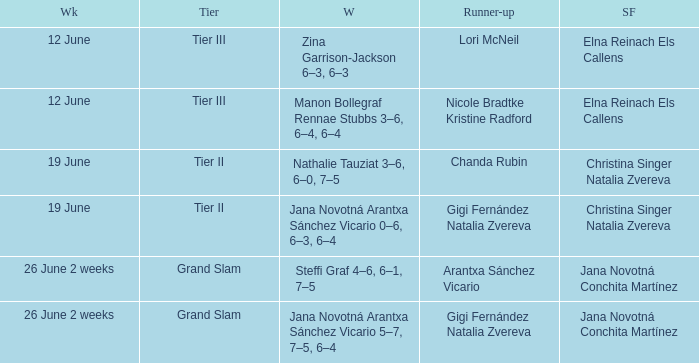Who are the semi finalists on the week of 12 june, when the runner-up is listed as Lori McNeil? Elna Reinach Els Callens. 